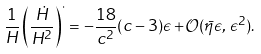<formula> <loc_0><loc_0><loc_500><loc_500>\frac { 1 } { H } \left ( \frac { \dot { H } } { H ^ { 2 } } \right ) ^ { \cdot } = - \frac { 1 8 } { c ^ { 2 } } ( c - 3 ) \epsilon + \mathcal { O } ( \bar { \eta } \epsilon , \, \epsilon ^ { 2 } ) .</formula> 